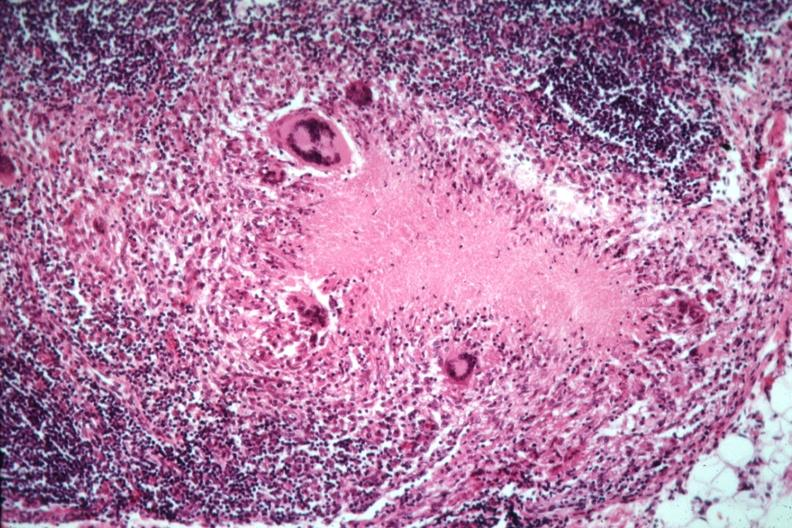s tuberculosis present?
Answer the question using a single word or phrase. Yes 